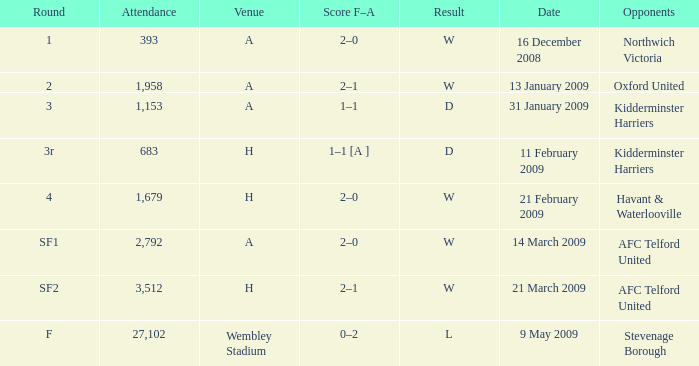What is the round on 21 february 2009? 4.0. 